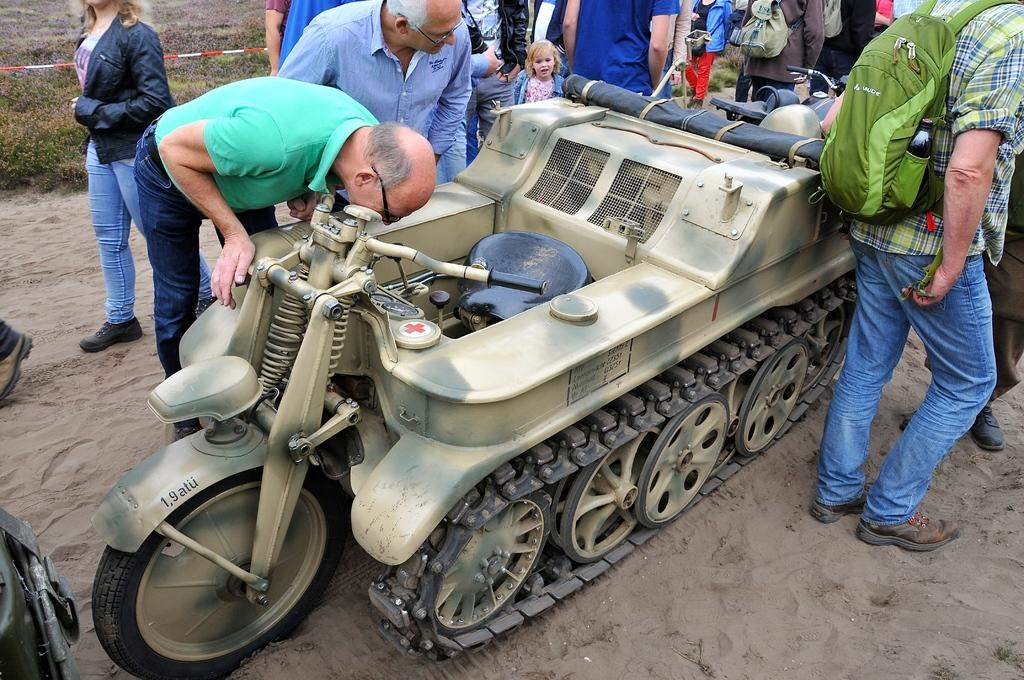What is the main object in the image? There is a vehicle in the image. How is the vehicle positioned in the image? The vehicle is placed on a surface. What else can be seen in the image besides the vehicle? There is a group of people standing around the vehicle, grass, plants, a ribbon, and a wall visible in the image. How does the woman jump over the vehicle in the image? There is no woman present in the image, and therefore no jumping over the vehicle can be observed. 